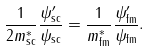Convert formula to latex. <formula><loc_0><loc_0><loc_500><loc_500>\frac { 1 } { 2 m ^ { * } _ { \text {sc} } } \frac { \psi ^ { \prime } _ { \text {sc} } } { \psi _ { \text {sc} } } = \frac { 1 } { m ^ { * } _ { \text {fm} } } \frac { \psi ^ { \prime } _ { \text {fm} } } { \psi _ { \text {fm} } } .</formula> 